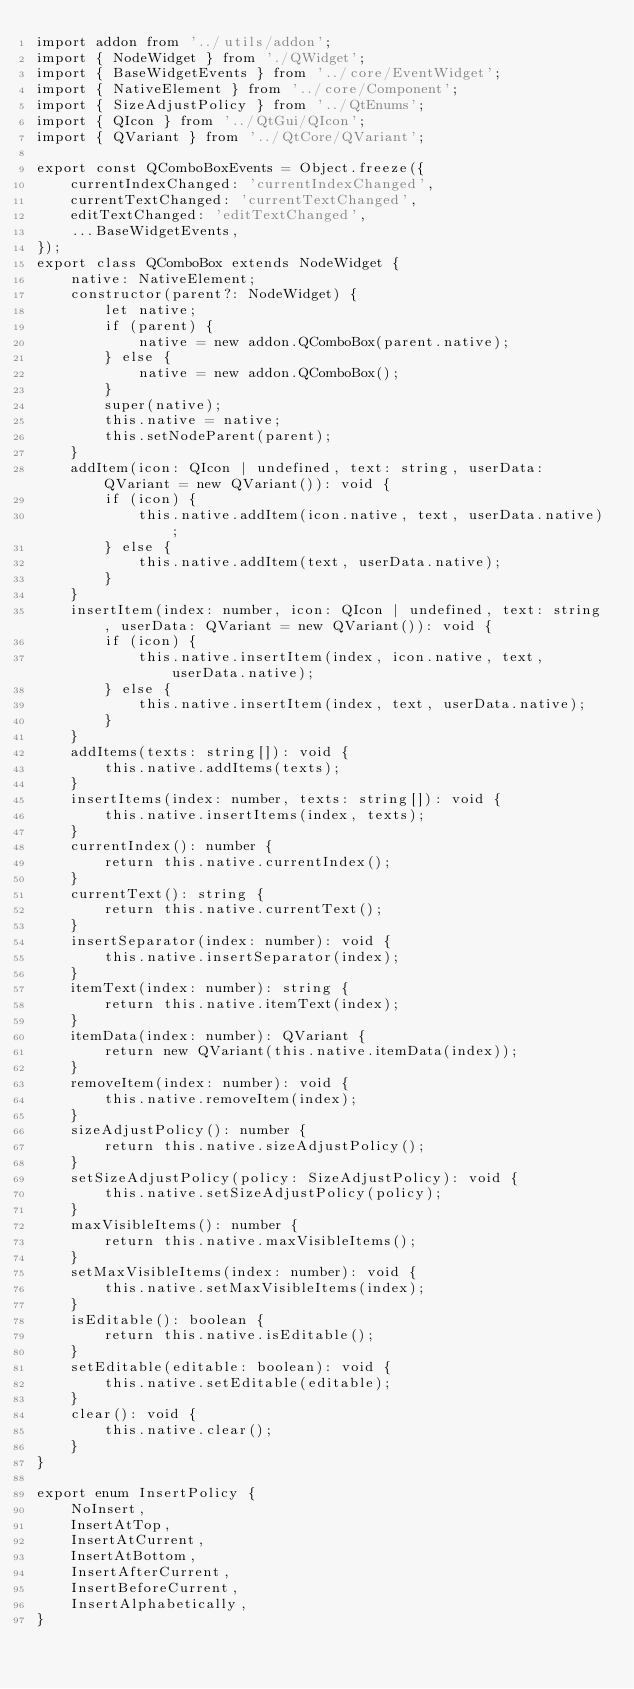Convert code to text. <code><loc_0><loc_0><loc_500><loc_500><_TypeScript_>import addon from '../utils/addon';
import { NodeWidget } from './QWidget';
import { BaseWidgetEvents } from '../core/EventWidget';
import { NativeElement } from '../core/Component';
import { SizeAdjustPolicy } from '../QtEnums';
import { QIcon } from '../QtGui/QIcon';
import { QVariant } from '../QtCore/QVariant';

export const QComboBoxEvents = Object.freeze({
    currentIndexChanged: 'currentIndexChanged',
    currentTextChanged: 'currentTextChanged',
    editTextChanged: 'editTextChanged',
    ...BaseWidgetEvents,
});
export class QComboBox extends NodeWidget {
    native: NativeElement;
    constructor(parent?: NodeWidget) {
        let native;
        if (parent) {
            native = new addon.QComboBox(parent.native);
        } else {
            native = new addon.QComboBox();
        }
        super(native);
        this.native = native;
        this.setNodeParent(parent);
    }
    addItem(icon: QIcon | undefined, text: string, userData: QVariant = new QVariant()): void {
        if (icon) {
            this.native.addItem(icon.native, text, userData.native);
        } else {
            this.native.addItem(text, userData.native);
        }
    }
    insertItem(index: number, icon: QIcon | undefined, text: string, userData: QVariant = new QVariant()): void {
        if (icon) {
            this.native.insertItem(index, icon.native, text, userData.native);
        } else {
            this.native.insertItem(index, text, userData.native);
        }
    }
    addItems(texts: string[]): void {
        this.native.addItems(texts);
    }
    insertItems(index: number, texts: string[]): void {
        this.native.insertItems(index, texts);
    }
    currentIndex(): number {
        return this.native.currentIndex();
    }
    currentText(): string {
        return this.native.currentText();
    }
    insertSeparator(index: number): void {
        this.native.insertSeparator(index);
    }
    itemText(index: number): string {
        return this.native.itemText(index);
    }
    itemData(index: number): QVariant {
        return new QVariant(this.native.itemData(index));
    }
    removeItem(index: number): void {
        this.native.removeItem(index);
    }
    sizeAdjustPolicy(): number {
        return this.native.sizeAdjustPolicy();
    }
    setSizeAdjustPolicy(policy: SizeAdjustPolicy): void {
        this.native.setSizeAdjustPolicy(policy);
    }
    maxVisibleItems(): number {
        return this.native.maxVisibleItems();
    }
    setMaxVisibleItems(index: number): void {
        this.native.setMaxVisibleItems(index);
    }
    isEditable(): boolean {
        return this.native.isEditable();
    }
    setEditable(editable: boolean): void {
        this.native.setEditable(editable);
    }
    clear(): void {
        this.native.clear();
    }
}

export enum InsertPolicy {
    NoInsert,
    InsertAtTop,
    InsertAtCurrent,
    InsertAtBottom,
    InsertAfterCurrent,
    InsertBeforeCurrent,
    InsertAlphabetically,
}
</code> 